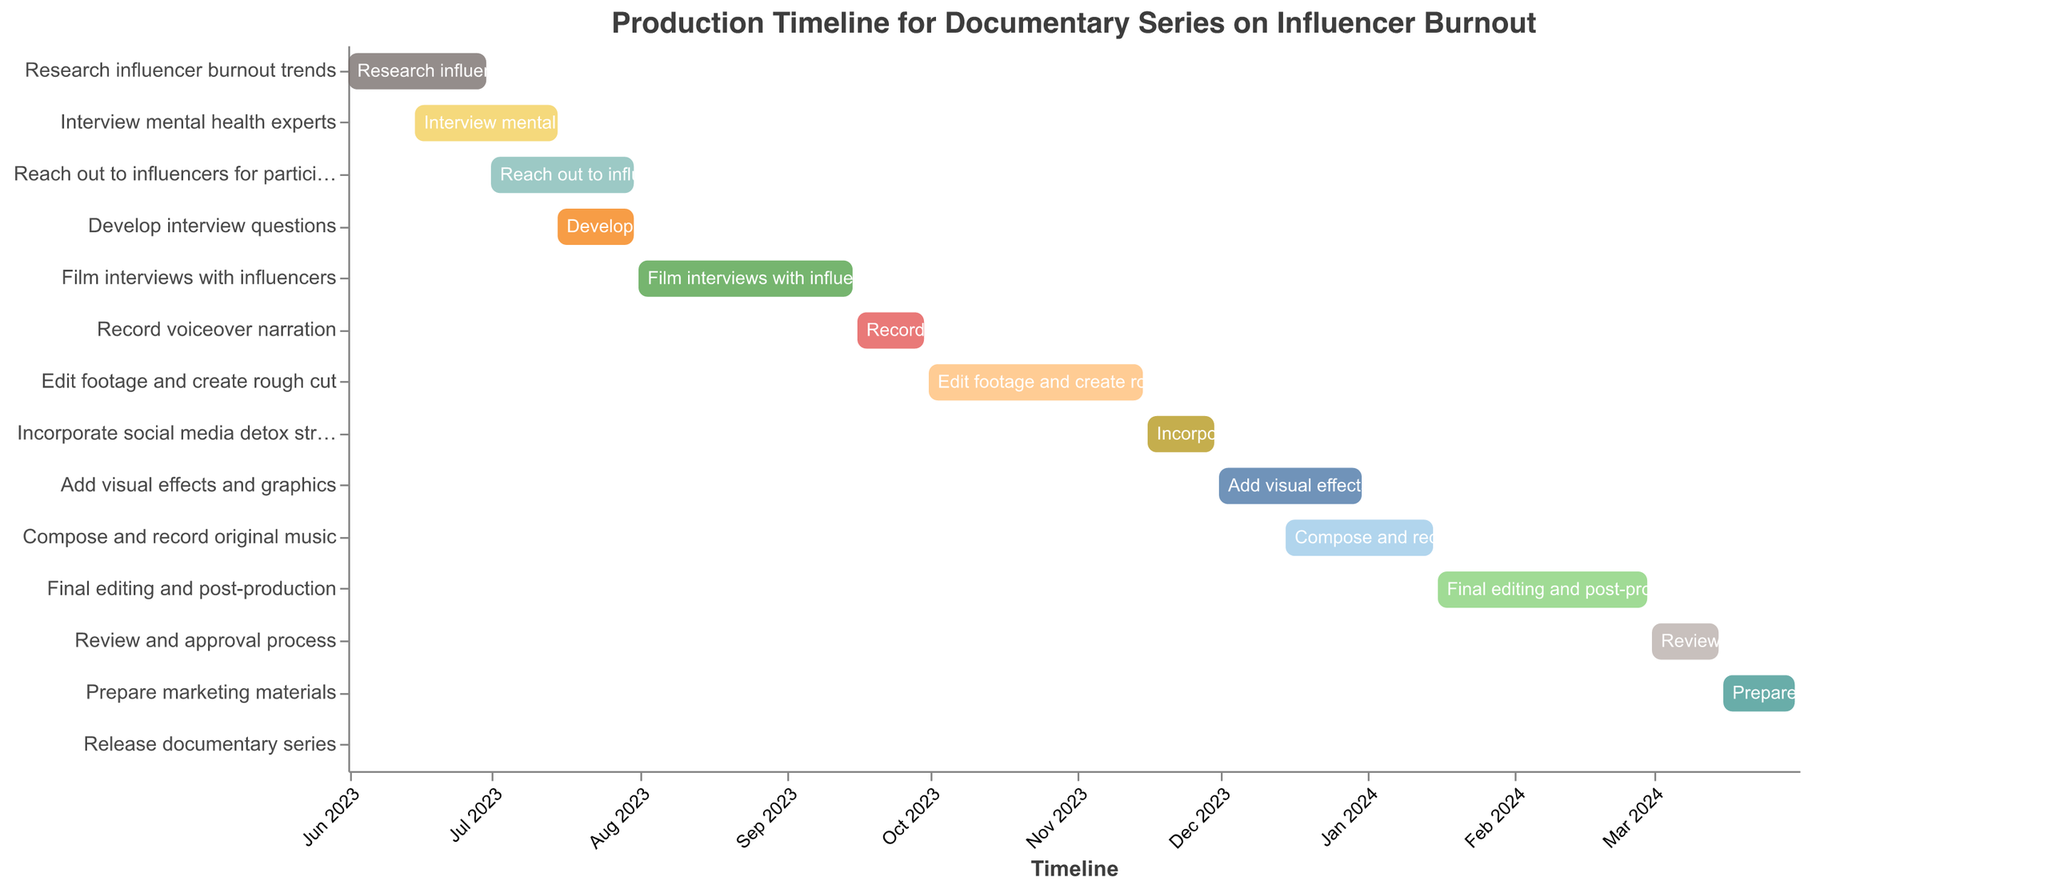What is the title of the Gantt chart? The title of the Gantt chart is located at the top of the figure. It says "Production Timeline for Documentary Series on Influencer Burnout".
Answer: Production Timeline for Documentary Series on Influencer Burnout Which task starts first according to the Gantt chart? The task that starts first is the one with the earliest "Start Date". "Research influencer burnout trends" starts on 2023-06-01, which is the earliest.
Answer: Research influencer burnout trends What is the duration of the "Film interviews with influencers" task? To find the duration of this task, you need to look at the corresponding row in the data where it states that it has a duration of 46 days.
Answer: 46 days When does the "Reach out to influencers for participation" task end? Look at the "End Date" for the task "Reach out to influencers for participation". It ends on 2023-07-31.
Answer: 2023-07-31 How many days is the "Review and approval process"? The duration column for "Review and approval process" shows the task lasts for 15 days.
Answer: 15 days Which task overlaps with both "Interview mental health experts" and "Reach out to influencers for participation"? To check overlapping tasks, identify tasks whose "Start Date" and "End Date" span the period in which "Interview mental health experts" and "Reach out to influencers for participation" occur. "Develop interview questions" overlaps with both, starting on 2023-07-15 and ending on 2023-07-31.
Answer: Develop interview questions Which task has the shortest duration, and how many days is it? Find the task with the shortest duration by scanning the Duration column. "Release documentary series" has the shortest duration of 1 day.
Answer: Release documentary series, 1 day How many tasks are scheduled to start in December 2023? Look for tasks with "Start Date" in December 2023. The tasks starting in December 2023 are "Add visual effects and graphics" and "Compose and record original music", making a total of 2 tasks.
Answer: 2 tasks Which task directly follows the "Edit footage and create rough cut" task? Identify the "End Date" of "Edit footage and create rough cut" and see the next task's "Start Date". The next task starting after 2023-11-15 is "Incorporate social media detox strategies" on 2023-11-16.
Answer: Incorporate social media detox strategies Compare the duration of "Add visual effects and graphics" and "Compose and record original music". Which one is longer, and by how many days? "Add visual effects and graphics" has a duration of 31 days, and "Compose and record original music" has a duration of 32 days. Comparing the two, "Compose and record original music" is longer by 1 day.
Answer: Compose and record original music, 1 day 